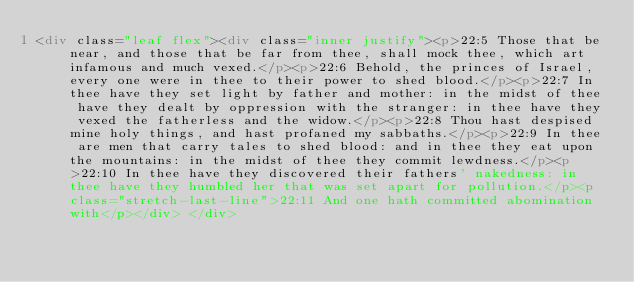<code> <loc_0><loc_0><loc_500><loc_500><_HTML_><div class="leaf flex"><div class="inner justify"><p>22:5 Those that be near, and those that be far from thee, shall mock thee, which art infamous and much vexed.</p><p>22:6 Behold, the princes of Israel, every one were in thee to their power to shed blood.</p><p>22:7 In thee have they set light by father and mother: in the midst of thee have they dealt by oppression with the stranger: in thee have they vexed the fatherless and the widow.</p><p>22:8 Thou hast despised mine holy things, and hast profaned my sabbaths.</p><p>22:9 In thee are men that carry tales to shed blood: and in thee they eat upon the mountains: in the midst of thee they commit lewdness.</p><p>22:10 In thee have they discovered their fathers' nakedness: in thee have they humbled her that was set apart for pollution.</p><p class="stretch-last-line">22:11 And one hath committed abomination with</p></div> </div></code> 